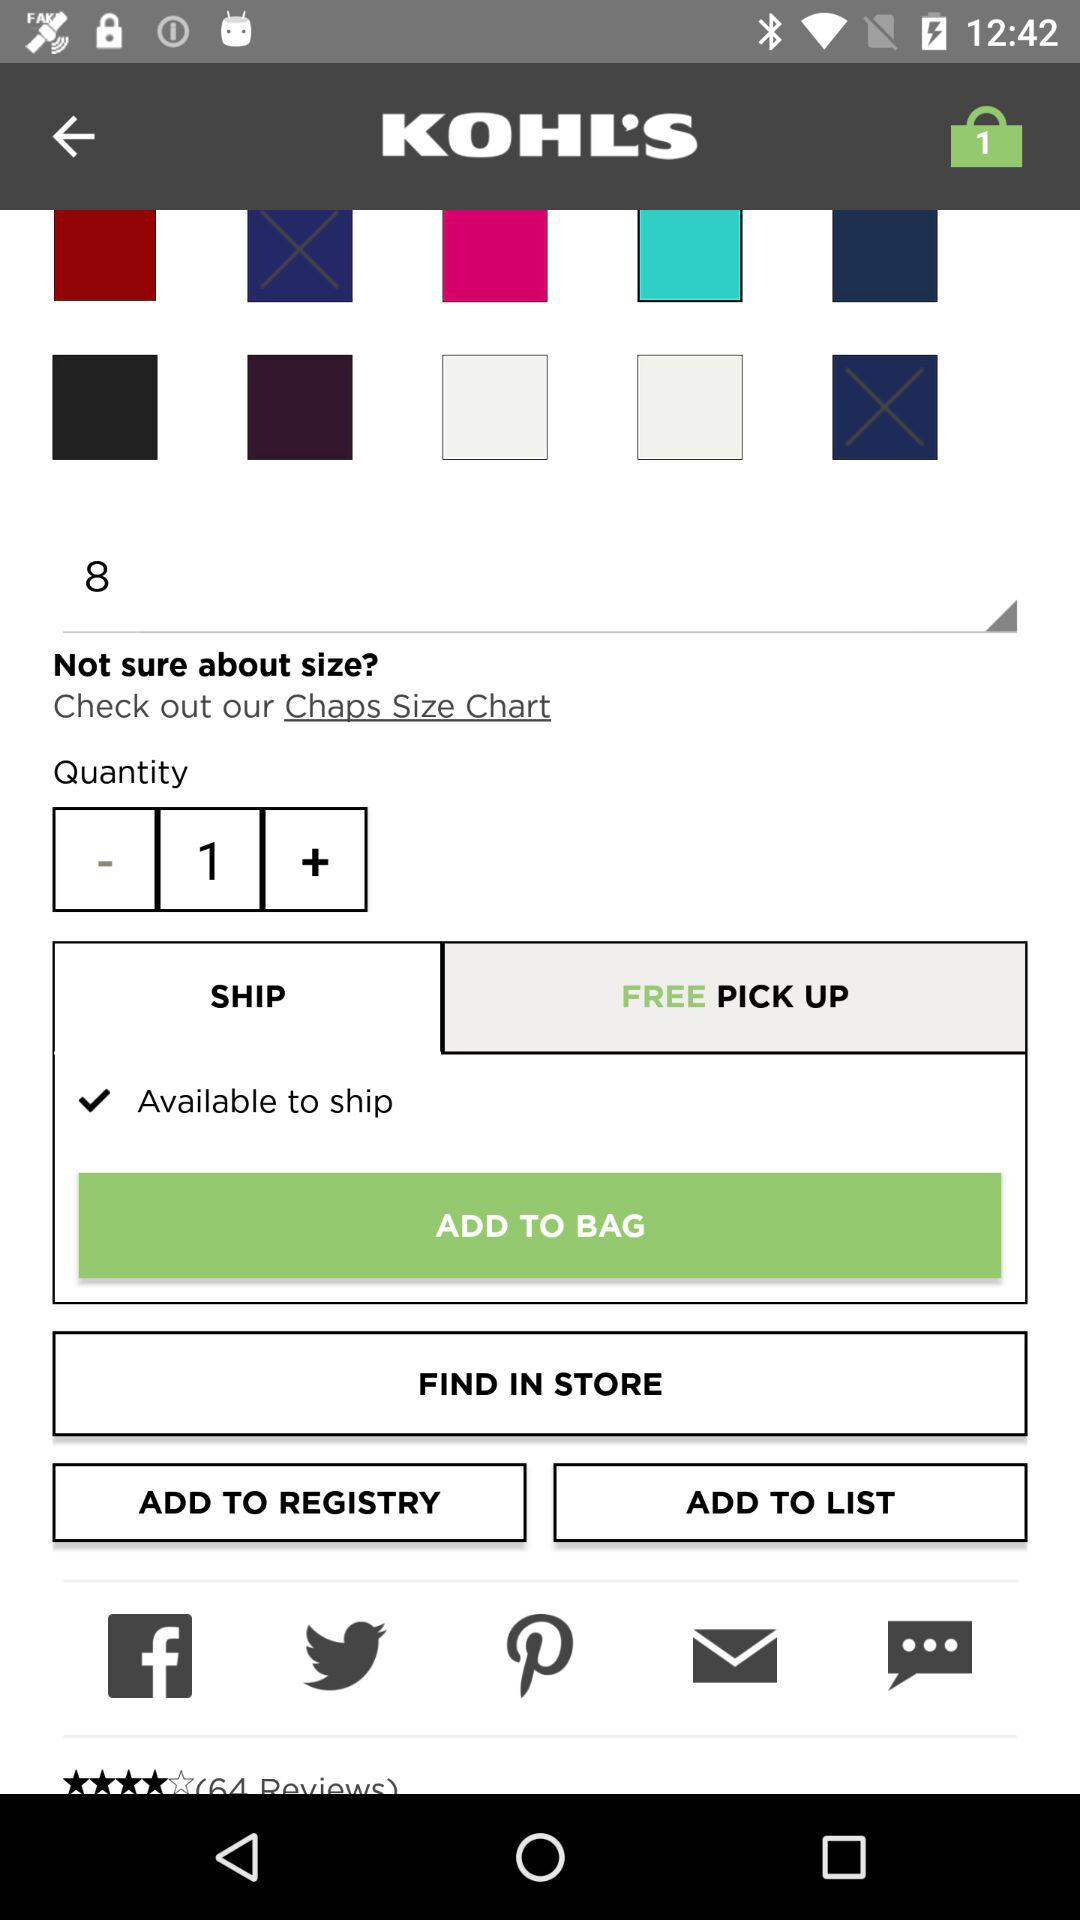Which size is selected? The selected size is 8. 